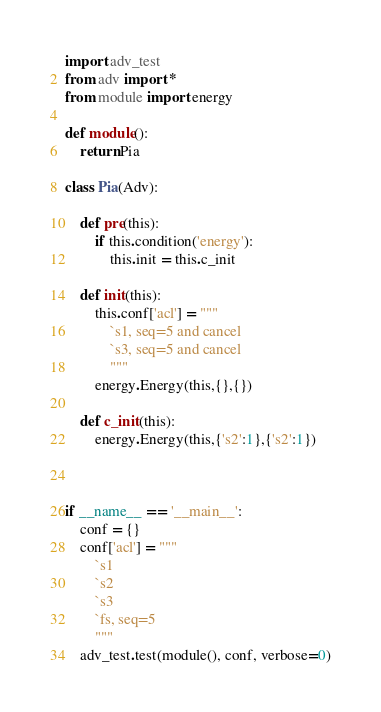Convert code to text. <code><loc_0><loc_0><loc_500><loc_500><_Python_>import adv_test
from adv import *
from module import energy

def module():
    return Pia

class Pia(Adv):

    def pre(this):
        if this.condition('energy'):
            this.init = this.c_init

    def init(this):
        this.conf['acl'] = """
            `s1, seq=5 and cancel 
            `s3, seq=5 and cancel
            """
        energy.Energy(this,{},{})

    def c_init(this):
        energy.Energy(this,{'s2':1},{'s2':1})



if __name__ == '__main__':
    conf = {}
    conf['acl'] = """
        `s1
        `s2
        `s3
        `fs, seq=5
        """
    adv_test.test(module(), conf, verbose=0)


</code> 